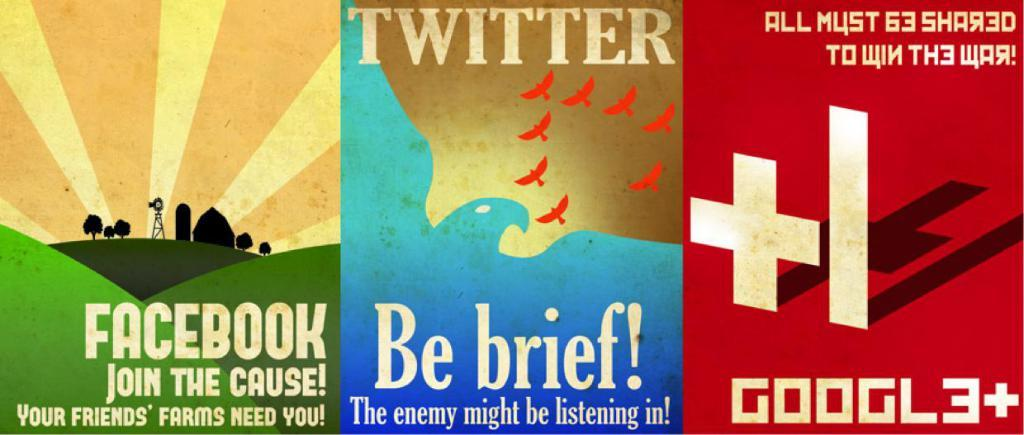<image>
Give a short and clear explanation of the subsequent image. Three posters for facebook twitter and google are next to each other. 